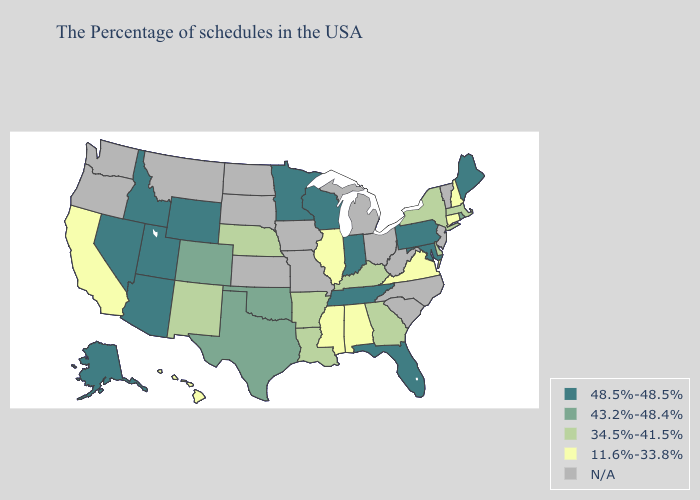Name the states that have a value in the range 43.2%-48.4%?
Write a very short answer. Rhode Island, Oklahoma, Texas, Colorado. Among the states that border Tennessee , which have the highest value?
Give a very brief answer. Georgia, Kentucky, Arkansas. Does Florida have the highest value in the South?
Give a very brief answer. Yes. Name the states that have a value in the range 48.5%-48.5%?
Write a very short answer. Maine, Maryland, Pennsylvania, Florida, Indiana, Tennessee, Wisconsin, Minnesota, Wyoming, Utah, Arizona, Idaho, Nevada, Alaska. Does Utah have the lowest value in the West?
Write a very short answer. No. Name the states that have a value in the range 11.6%-33.8%?
Short answer required. New Hampshire, Connecticut, Virginia, Alabama, Illinois, Mississippi, California, Hawaii. Name the states that have a value in the range 11.6%-33.8%?
Give a very brief answer. New Hampshire, Connecticut, Virginia, Alabama, Illinois, Mississippi, California, Hawaii. What is the lowest value in the USA?
Be succinct. 11.6%-33.8%. What is the lowest value in the MidWest?
Write a very short answer. 11.6%-33.8%. Name the states that have a value in the range 11.6%-33.8%?
Quick response, please. New Hampshire, Connecticut, Virginia, Alabama, Illinois, Mississippi, California, Hawaii. Name the states that have a value in the range 43.2%-48.4%?
Give a very brief answer. Rhode Island, Oklahoma, Texas, Colorado. Which states have the lowest value in the USA?
Answer briefly. New Hampshire, Connecticut, Virginia, Alabama, Illinois, Mississippi, California, Hawaii. Which states have the lowest value in the USA?
Answer briefly. New Hampshire, Connecticut, Virginia, Alabama, Illinois, Mississippi, California, Hawaii. How many symbols are there in the legend?
Short answer required. 5. Name the states that have a value in the range 11.6%-33.8%?
Short answer required. New Hampshire, Connecticut, Virginia, Alabama, Illinois, Mississippi, California, Hawaii. 